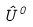<formula> <loc_0><loc_0><loc_500><loc_500>\hat { U } ^ { 0 }</formula> 